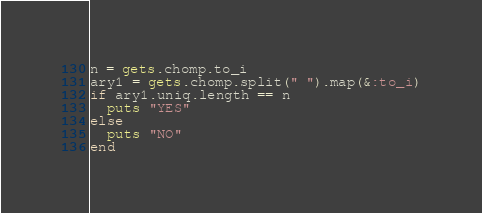Convert code to text. <code><loc_0><loc_0><loc_500><loc_500><_Ruby_>n = gets.chomp.to_i
ary1 = gets.chomp.split(" ").map(&:to_i)
if ary1.uniq.length == n
  puts "YES"
else
  puts "NO"
end
</code> 